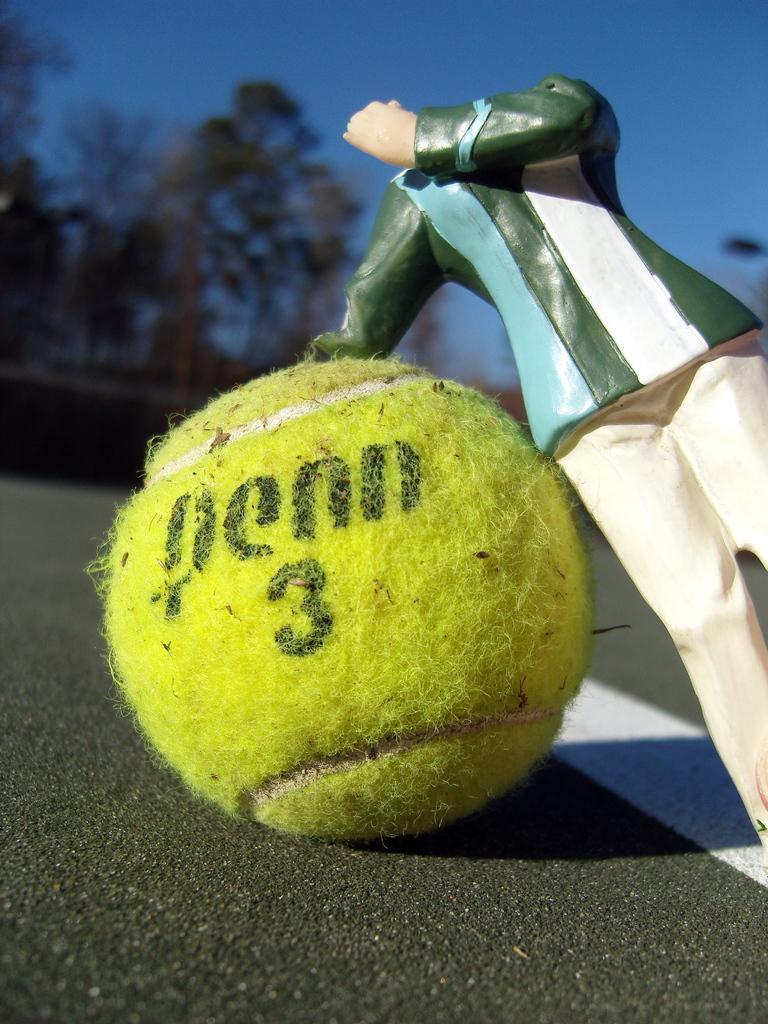Could you give a brief overview of what you see in this image? In this picture, we see a ball in yellow color. Beside that, we see a toy. At the bottom, we see the road. There are trees in the background. At the top, we see the sky. This picture is blurred in the background. 